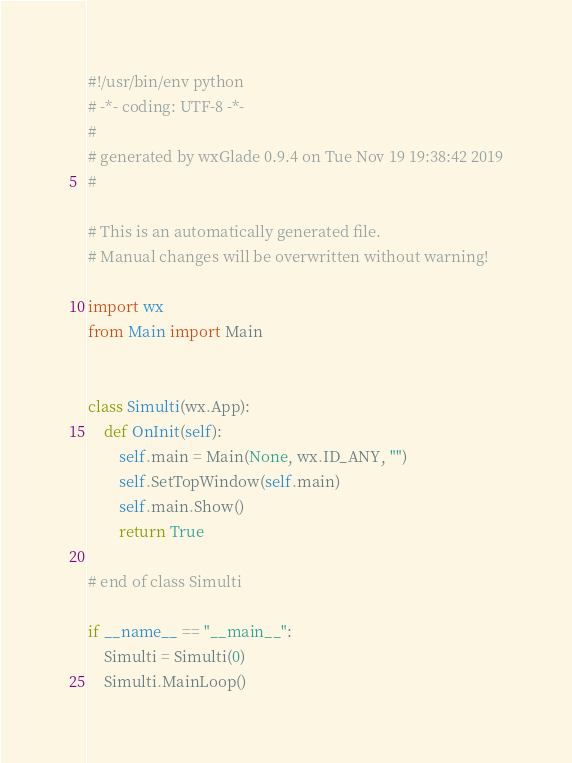Convert code to text. <code><loc_0><loc_0><loc_500><loc_500><_Python_>#!/usr/bin/env python
# -*- coding: UTF-8 -*-
#
# generated by wxGlade 0.9.4 on Tue Nov 19 19:38:42 2019
#

# This is an automatically generated file.
# Manual changes will be overwritten without warning!

import wx
from Main import Main


class Simulti(wx.App):
    def OnInit(self):
        self.main = Main(None, wx.ID_ANY, "")
        self.SetTopWindow(self.main)
        self.main.Show()
        return True

# end of class Simulti

if __name__ == "__main__":
    Simulti = Simulti(0)
    Simulti.MainLoop()
</code> 